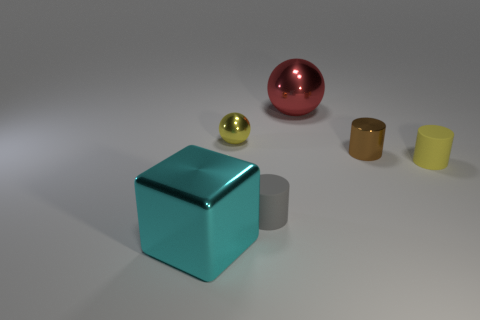Is the shape of the cyan object the same as the small brown thing?
Make the answer very short. No. What number of other objects are there of the same size as the shiny cube?
Your answer should be compact. 1. How many things are large objects in front of the red sphere or large cyan rubber cylinders?
Your response must be concise. 1. The tiny metallic sphere has what color?
Your response must be concise. Yellow. There is a small yellow thing left of the tiny gray thing; what is it made of?
Your answer should be compact. Metal. There is a gray matte thing; is its shape the same as the small yellow object on the right side of the tiny yellow ball?
Offer a very short reply. Yes. Are there more tiny objects than objects?
Ensure brevity in your answer.  No. Is there anything else of the same color as the small ball?
Ensure brevity in your answer.  Yes. What shape is the brown object that is the same material as the block?
Give a very brief answer. Cylinder. What is the large object behind the big shiny thing that is in front of the large red metallic thing made of?
Provide a succinct answer. Metal. 